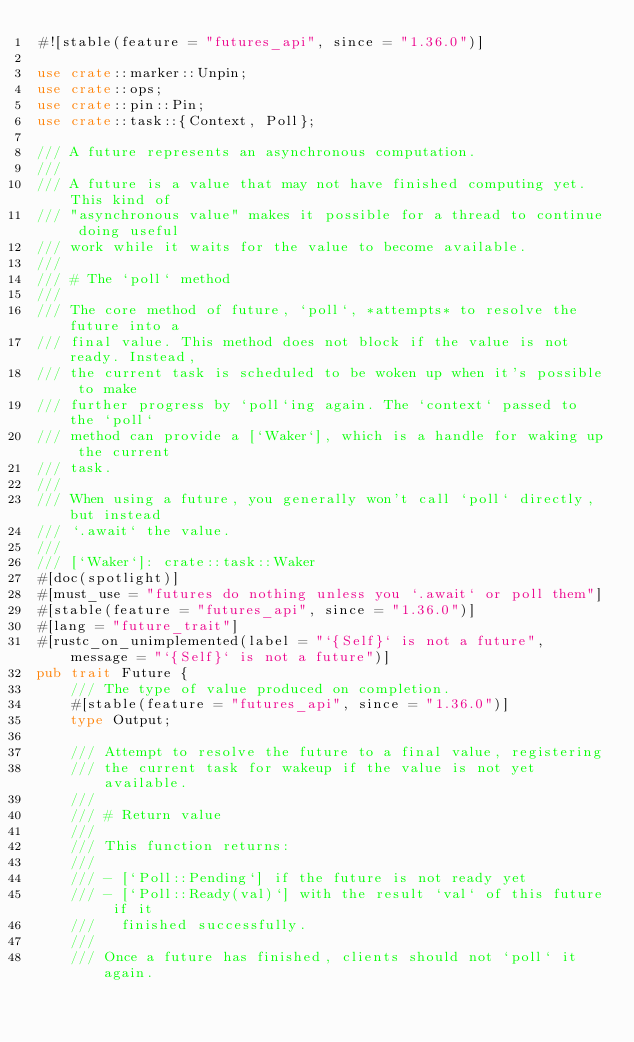<code> <loc_0><loc_0><loc_500><loc_500><_Rust_>#![stable(feature = "futures_api", since = "1.36.0")]

use crate::marker::Unpin;
use crate::ops;
use crate::pin::Pin;
use crate::task::{Context, Poll};

/// A future represents an asynchronous computation.
///
/// A future is a value that may not have finished computing yet. This kind of
/// "asynchronous value" makes it possible for a thread to continue doing useful
/// work while it waits for the value to become available.
///
/// # The `poll` method
///
/// The core method of future, `poll`, *attempts* to resolve the future into a
/// final value. This method does not block if the value is not ready. Instead,
/// the current task is scheduled to be woken up when it's possible to make
/// further progress by `poll`ing again. The `context` passed to the `poll`
/// method can provide a [`Waker`], which is a handle for waking up the current
/// task.
///
/// When using a future, you generally won't call `poll` directly, but instead
/// `.await` the value.
///
/// [`Waker`]: crate::task::Waker
#[doc(spotlight)]
#[must_use = "futures do nothing unless you `.await` or poll them"]
#[stable(feature = "futures_api", since = "1.36.0")]
#[lang = "future_trait"]
#[rustc_on_unimplemented(label = "`{Self}` is not a future", message = "`{Self}` is not a future")]
pub trait Future {
    /// The type of value produced on completion.
    #[stable(feature = "futures_api", since = "1.36.0")]
    type Output;

    /// Attempt to resolve the future to a final value, registering
    /// the current task for wakeup if the value is not yet available.
    ///
    /// # Return value
    ///
    /// This function returns:
    ///
    /// - [`Poll::Pending`] if the future is not ready yet
    /// - [`Poll::Ready(val)`] with the result `val` of this future if it
    ///   finished successfully.
    ///
    /// Once a future has finished, clients should not `poll` it again.</code> 